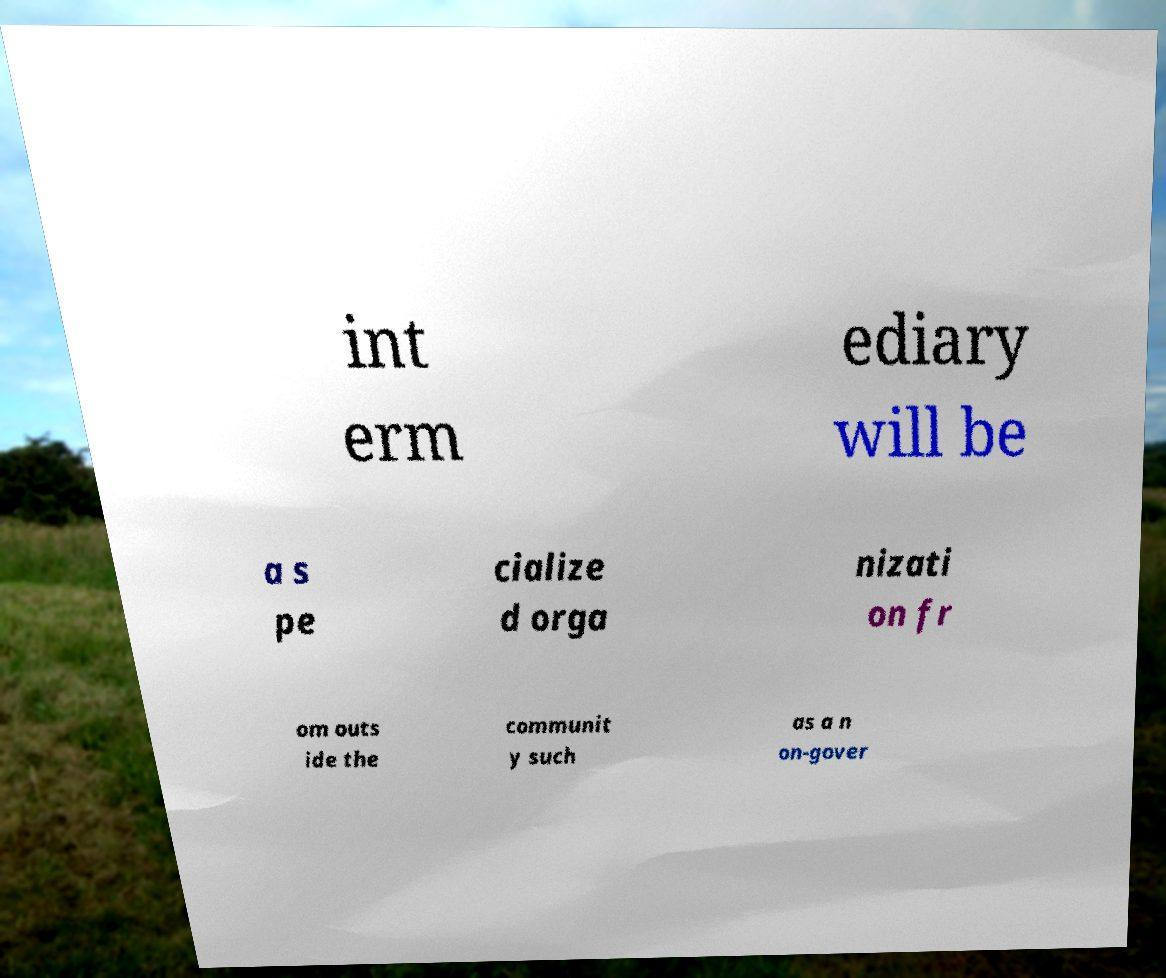Could you assist in decoding the text presented in this image and type it out clearly? int erm ediary will be a s pe cialize d orga nizati on fr om outs ide the communit y such as a n on-gover 